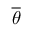Convert formula to latex. <formula><loc_0><loc_0><loc_500><loc_500>\overline { \theta }</formula> 